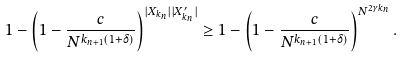Convert formula to latex. <formula><loc_0><loc_0><loc_500><loc_500>1 - \left ( 1 - \frac { c } { N ^ { k _ { n + 1 } ( 1 + \delta ) } } \right ) ^ { | X _ { k _ { n } } | | X ^ { \prime } _ { k _ { n } } | } \geq 1 - \left ( 1 - \frac { c } { N ^ { k _ { n + 1 } ( 1 + \delta ) } } \right ) ^ { N ^ { 2 \gamma k _ { n } } } .</formula> 